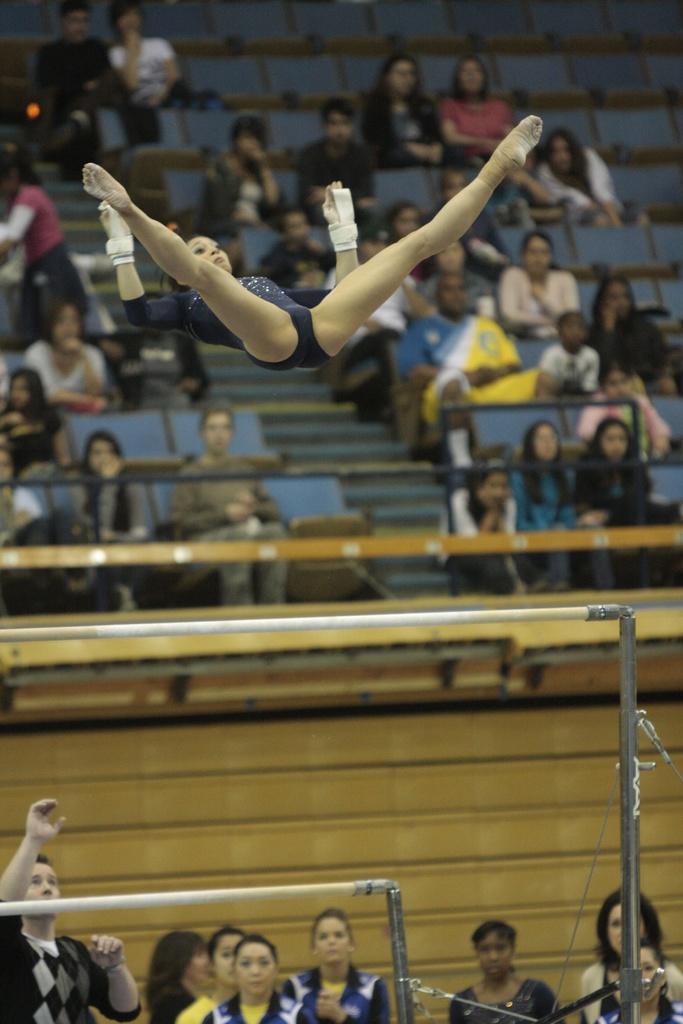Could you give a brief overview of what you see in this image? In this image I see a woman over here and I see the rods over here and I see few people over here. In the background I see few more people who are sitting on chairs. 